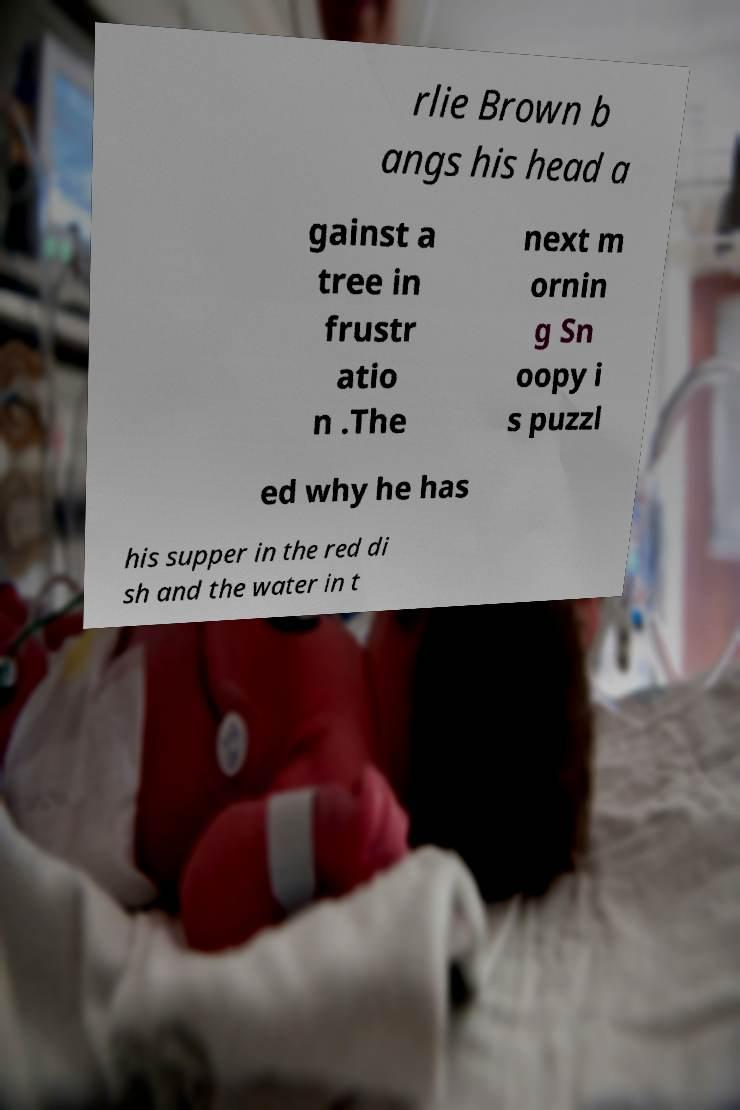Can you read and provide the text displayed in the image?This photo seems to have some interesting text. Can you extract and type it out for me? rlie Brown b angs his head a gainst a tree in frustr atio n .The next m ornin g Sn oopy i s puzzl ed why he has his supper in the red di sh and the water in t 